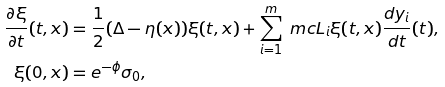Convert formula to latex. <formula><loc_0><loc_0><loc_500><loc_500>\frac { \partial \xi } { \partial t } ( t , x ) & = \frac { 1 } { 2 } ( \Delta - \eta ( x ) ) \xi ( t , x ) + \sum _ { i = 1 } ^ { m } \ m c { L } _ { i } \xi ( t , x ) \frac { d y _ { i } } { d t } ( t ) , \\ \xi ( 0 , x ) & = e ^ { - \phi } \sigma _ { 0 } ,</formula> 